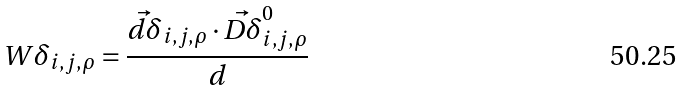Convert formula to latex. <formula><loc_0><loc_0><loc_500><loc_500>W \delta _ { i , j , \rho } = \frac { \vec { d \delta } _ { i , j , \rho } \cdot \vec { D \delta } ^ { 0 } _ { i , j , \rho } } { d }</formula> 